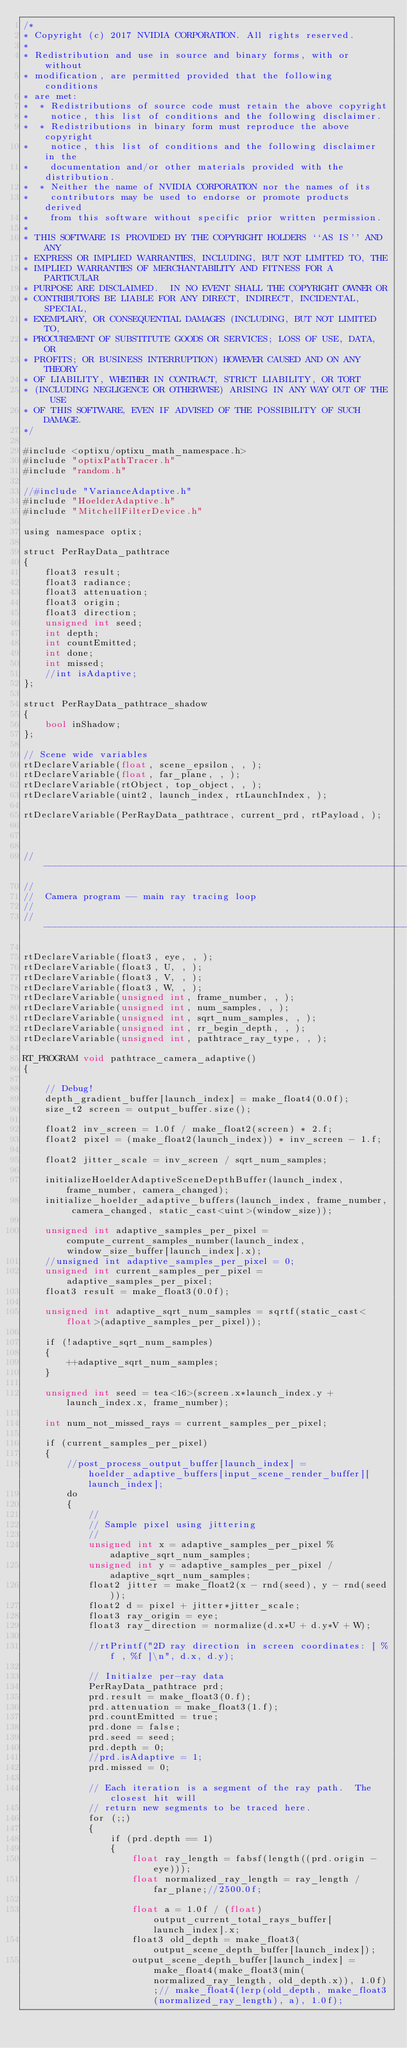<code> <loc_0><loc_0><loc_500><loc_500><_Cuda_>/*
* Copyright (c) 2017 NVIDIA CORPORATION. All rights reserved.
*
* Redistribution and use in source and binary forms, with or without
* modification, are permitted provided that the following conditions
* are met:
*  * Redistributions of source code must retain the above copyright
*    notice, this list of conditions and the following disclaimer.
*  * Redistributions in binary form must reproduce the above copyright
*    notice, this list of conditions and the following disclaimer in the
*    documentation and/or other materials provided with the distribution.
*  * Neither the name of NVIDIA CORPORATION nor the names of its
*    contributors may be used to endorse or promote products derived
*    from this software without specific prior written permission.
*
* THIS SOFTWARE IS PROVIDED BY THE COPYRIGHT HOLDERS ``AS IS'' AND ANY
* EXPRESS OR IMPLIED WARRANTIES, INCLUDING, BUT NOT LIMITED TO, THE
* IMPLIED WARRANTIES OF MERCHANTABILITY AND FITNESS FOR A PARTICULAR
* PURPOSE ARE DISCLAIMED.  IN NO EVENT SHALL THE COPYRIGHT OWNER OR
* CONTRIBUTORS BE LIABLE FOR ANY DIRECT, INDIRECT, INCIDENTAL, SPECIAL,
* EXEMPLARY, OR CONSEQUENTIAL DAMAGES (INCLUDING, BUT NOT LIMITED TO,
* PROCUREMENT OF SUBSTITUTE GOODS OR SERVICES; LOSS OF USE, DATA, OR
* PROFITS; OR BUSINESS INTERRUPTION) HOWEVER CAUSED AND ON ANY THEORY
* OF LIABILITY, WHETHER IN CONTRACT, STRICT LIABILITY, OR TORT
* (INCLUDING NEGLIGENCE OR OTHERWISE) ARISING IN ANY WAY OUT OF THE USE
* OF THIS SOFTWARE, EVEN IF ADVISED OF THE POSSIBILITY OF SUCH DAMAGE.
*/

#include <optixu/optixu_math_namespace.h>
#include "optixPathTracer.h"
#include "random.h"

//#include "VarianceAdaptive.h"
#include "HoelderAdaptive.h"
#include "MitchellFilterDevice.h"

using namespace optix;

struct PerRayData_pathtrace
{
	float3 result;
	float3 radiance;
	float3 attenuation;
	float3 origin;
	float3 direction;
	unsigned int seed;
	int depth;
	int countEmitted;
	int done;
	int missed;
	//int isAdaptive;
};

struct PerRayData_pathtrace_shadow
{
	bool inShadow;
};

// Scene wide variables
rtDeclareVariable(float, scene_epsilon, , );
rtDeclareVariable(float, far_plane, , );
rtDeclareVariable(rtObject, top_object, , );
rtDeclareVariable(uint2, launch_index, rtLaunchIndex, );

rtDeclareVariable(PerRayData_pathtrace, current_prd, rtPayload, );



//-----------------------------------------------------------------------------
//
//  Camera program -- main ray tracing loop
//
//-----------------------------------------------------------------------------

rtDeclareVariable(float3, eye, , );
rtDeclareVariable(float3, U, , );
rtDeclareVariable(float3, V, , );
rtDeclareVariable(float3, W, , );
rtDeclareVariable(unsigned int, frame_number, , );
rtDeclareVariable(unsigned int, num_samples, , );
rtDeclareVariable(unsigned int, sqrt_num_samples, , );
rtDeclareVariable(unsigned int, rr_begin_depth, , );
rtDeclareVariable(unsigned int, pathtrace_ray_type, , );

RT_PROGRAM void pathtrace_camera_adaptive()
{

	// Debug!
	depth_gradient_buffer[launch_index] = make_float4(0.0f);
	size_t2 screen = output_buffer.size();

	float2 inv_screen = 1.0f / make_float2(screen) * 2.f;
	float2 pixel = (make_float2(launch_index)) * inv_screen - 1.f;

	float2 jitter_scale = inv_screen / sqrt_num_samples;

	initializeHoelderAdaptiveSceneDepthBuffer(launch_index, frame_number, camera_changed);
	initialize_hoelder_adaptive_buffers(launch_index, frame_number, camera_changed, static_cast<uint>(window_size));

	unsigned int adaptive_samples_per_pixel = compute_current_samples_number(launch_index, window_size_buffer[launch_index].x);
	//unsigned int adaptive_samples_per_pixel = 0;
	unsigned int current_samples_per_pixel = adaptive_samples_per_pixel;
	float3 result = make_float3(0.0f);

	unsigned int adaptive_sqrt_num_samples = sqrtf(static_cast<float>(adaptive_samples_per_pixel));

	if (!adaptive_sqrt_num_samples)
	{
		++adaptive_sqrt_num_samples;
	}

	unsigned int seed = tea<16>(screen.x*launch_index.y + launch_index.x, frame_number);

	int num_not_missed_rays = current_samples_per_pixel;

	if (current_samples_per_pixel)
	{
		//post_process_output_buffer[launch_index] = hoelder_adaptive_buffers[input_scene_render_buffer][launch_index];
		do
		{
			//
			// Sample pixel using jittering
			//
			unsigned int x = adaptive_samples_per_pixel % adaptive_sqrt_num_samples;
			unsigned int y = adaptive_samples_per_pixel / adaptive_sqrt_num_samples;
			float2 jitter = make_float2(x - rnd(seed), y - rnd(seed));
			float2 d = pixel + jitter*jitter_scale;
			float3 ray_origin = eye;
			float3 ray_direction = normalize(d.x*U + d.y*V + W);

			//rtPrintf("2D ray direction in screen coordinates: [ %f , %f ]\n", d.x, d.y);

			// Initialze per-ray data
			PerRayData_pathtrace prd;
			prd.result = make_float3(0.f);
			prd.attenuation = make_float3(1.f);
			prd.countEmitted = true;
			prd.done = false;
			prd.seed = seed;
			prd.depth = 0;
			//prd.isAdaptive = 1;
			prd.missed = 0;

			// Each iteration is a segment of the ray path.  The closest hit will
			// return new segments to be traced here.
			for (;;)
			{
				if (prd.depth == 1)
				{
					float ray_length = fabsf(length((prd.origin - eye)));
					float normalized_ray_length = ray_length / far_plane;//2500.0f;

					float a = 1.0f / (float)output_current_total_rays_buffer[launch_index].x;
					float3 old_depth = make_float3(output_scene_depth_buffer[launch_index]);
					output_scene_depth_buffer[launch_index] = make_float4(make_float3(min(normalized_ray_length, old_depth.x)), 1.0f);// make_float4(lerp(old_depth, make_float3(normalized_ray_length), a), 1.0f);
</code> 